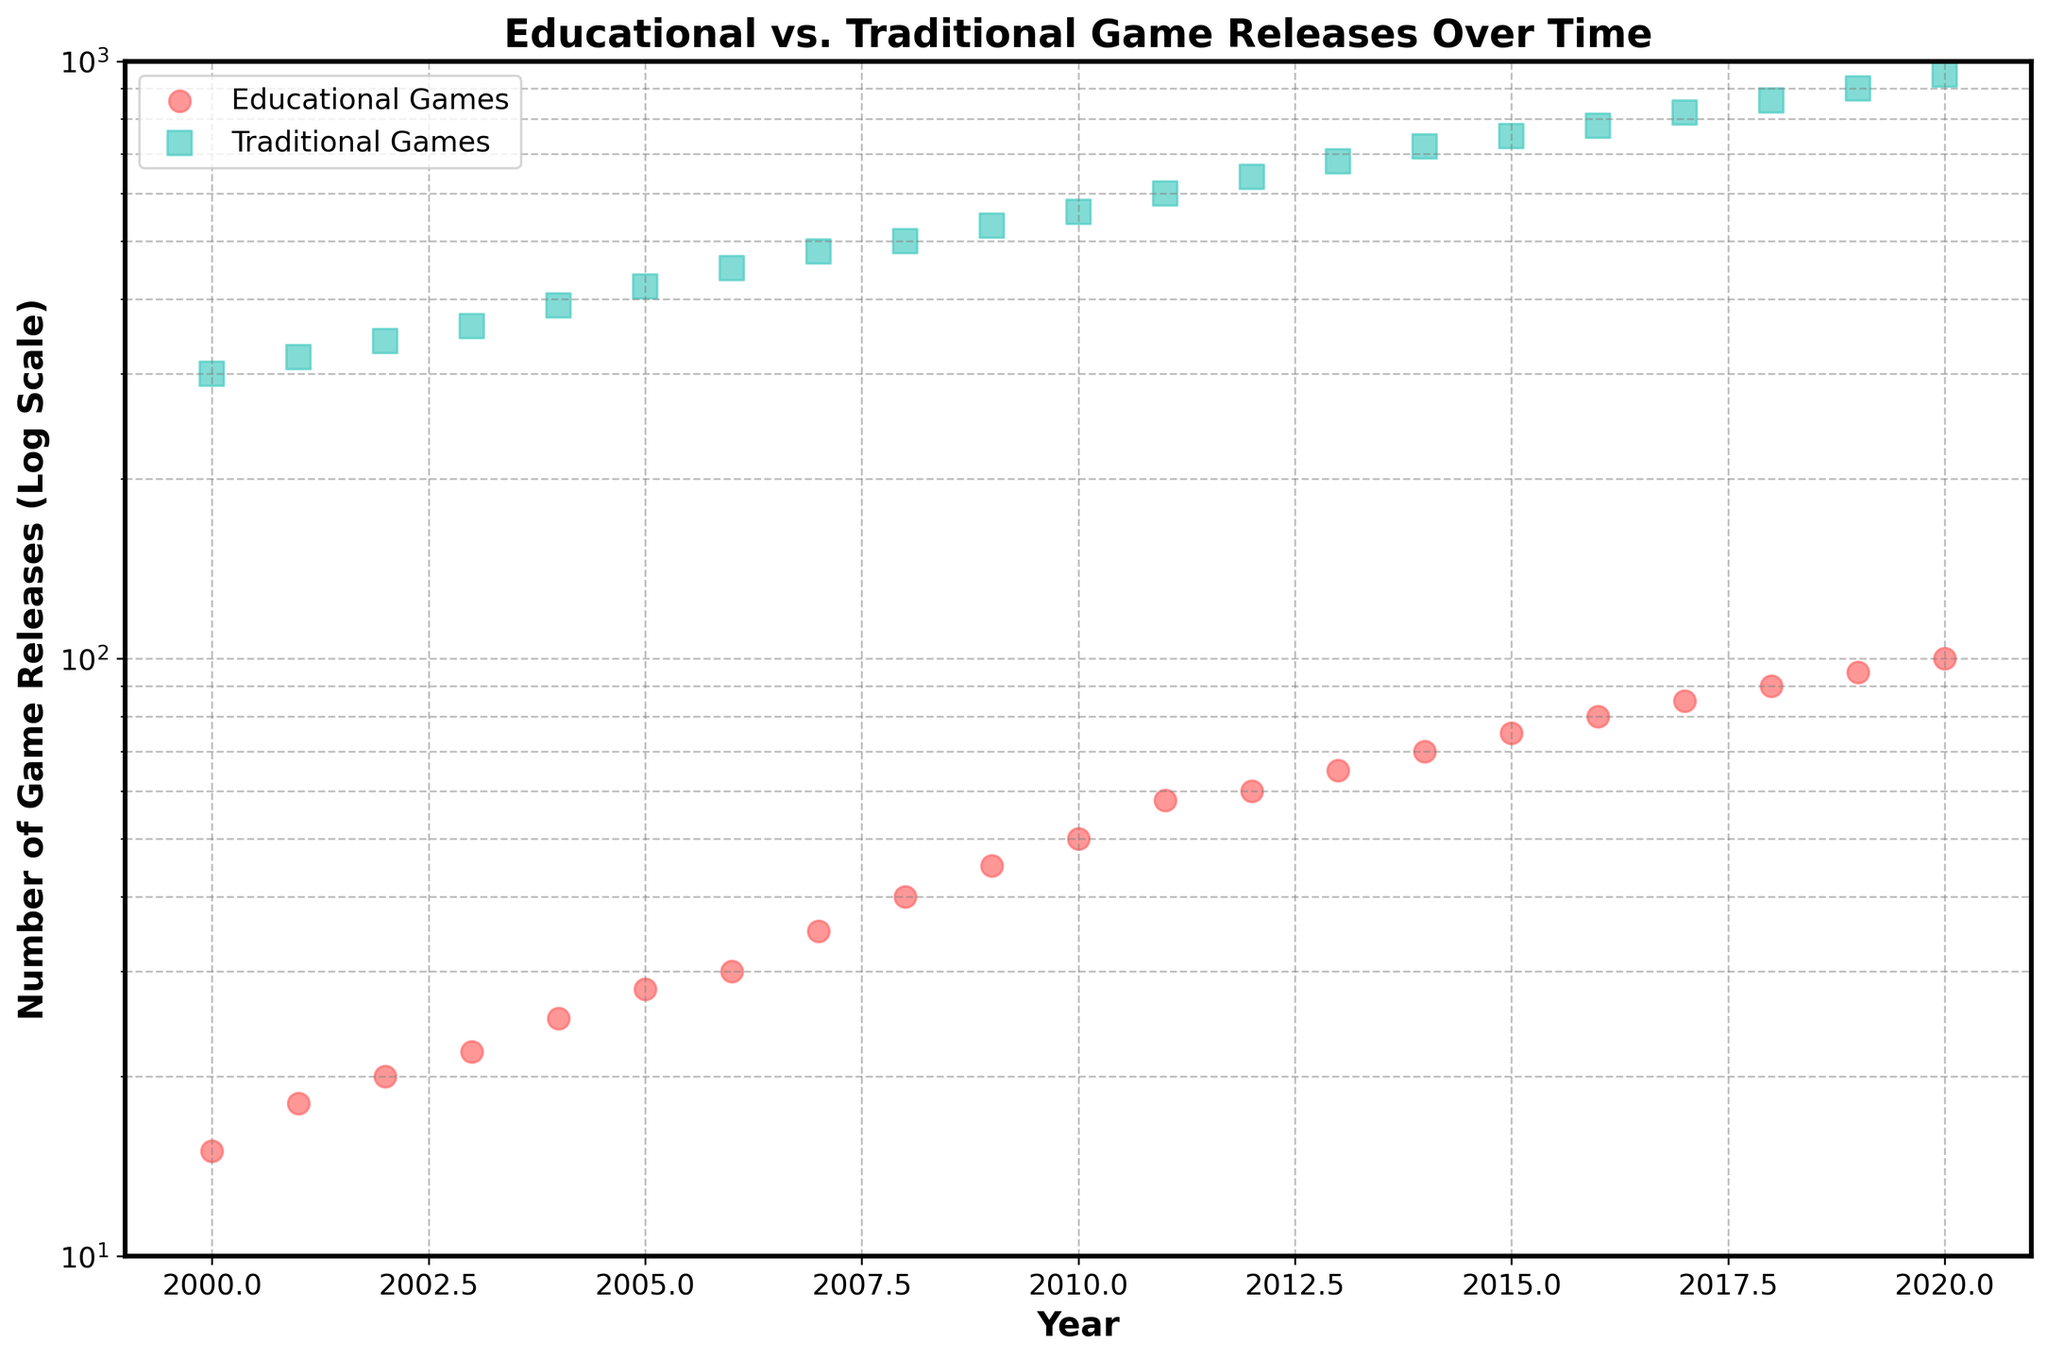What is the title of the scatter plot? The title is positioned at the top of the scatter plot and reads "Educational vs. Traditional Game Releases Over Time." This is plain text in a bold, large font.
Answer: Educational vs. Traditional Game Releases Over Time What is the y-axis labeled? The y-axis is labeled "Number of Game Releases (Log Scale)," as indicated on the left side of the plot in bold text.
Answer: Number of Game Releases (Log Scale) Which type of game had more releases in the year 2010? In the year 2010, the coordinate for traditional games (square marker) is at a higher y-value compared to the coordinate for educational games (circle marker).
Answer: Traditional games How many data points are there for educational games? There is one data point for each year from 2000 to 2020, inclusive, which results in a total of 21 data points.
Answer: 21 How much faster did traditional game releases increase compared to educational games from 2000 to 2020? The releases in 2000 for traditional were 300 and reached 950 by 2020, while educational games started from 15 and reached 100. This means traditional games increased by (950 - 300) = 650, and educational games by (100 - 15) = 85. The rate for traditional games over educational games is given by 650 / 85 or approximately 7.65 times faster.
Answer: 7.65 times Compare the trends for educational and traditional game releases from 2015 to 2020. From 2015 to 2020, both types of games consistently increased. Educational games increased from 75 to 100, a difference of 25. Traditional games increased from 750 to 950, a difference of 200. Traditional games consistently maintain a larger absolute increase each year.
Answer: Both trends increased, traditional increased more What is the approximate log-scale value range shown on the y-axis? The y-axis ranges from 10 to 1000, which is displayed in log scale. This is evident from the logarithmic progression of the tick marks on the y-axis.
Answer: 10 to 1000 Which year saw the highest released number of educational games, and how many were there? The highest released number of educational games occurred in the year 2020. Referring to the y-coordinate of the circle marker for 2020, it reaches 100.
Answer: 2020, 100 games 